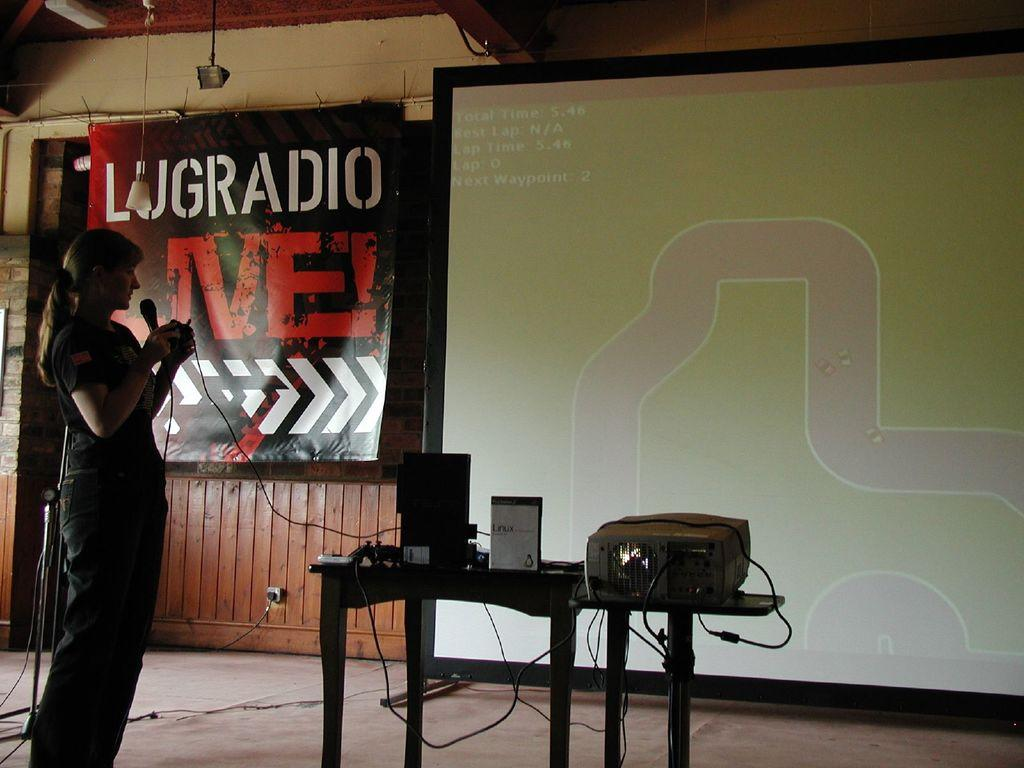Who is present in the image? There is the main subject of the image? What is the woman doing in the image? The woman is standing in the image. What object is the woman holding in her hand? The woman is holding a microphone in her hand. What type of agreement is being signed by the woman in the image? There is no agreement or signing activity depicted in the image; the woman is holding a microphone, which suggests she might be speaking or performing, but there is no indication of a signing activity in the image. 